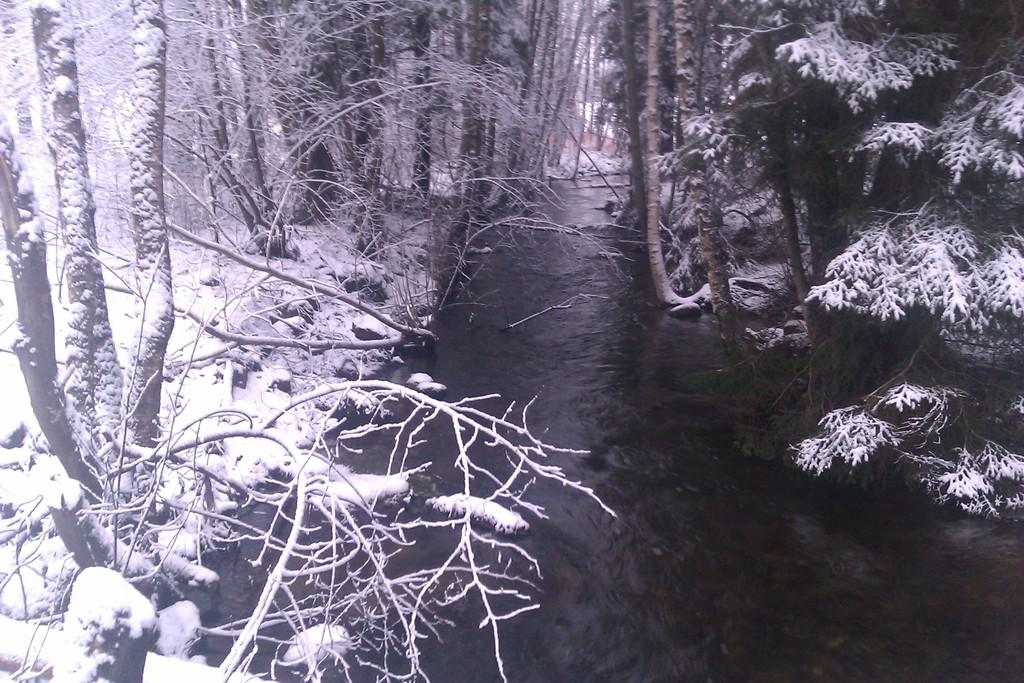What is the main feature in the middle of the image? There is a river in the middle of the image. What can be seen in the background of the image? There are trees in the background of the image. What type of form or stage is visible in the image? There is no form or stage present in the image; it features a river and trees. What color is the shirt worn by the tree in the image? Trees do not wear shirts, and there is no person or object in the image that could be wearing a shirt. 